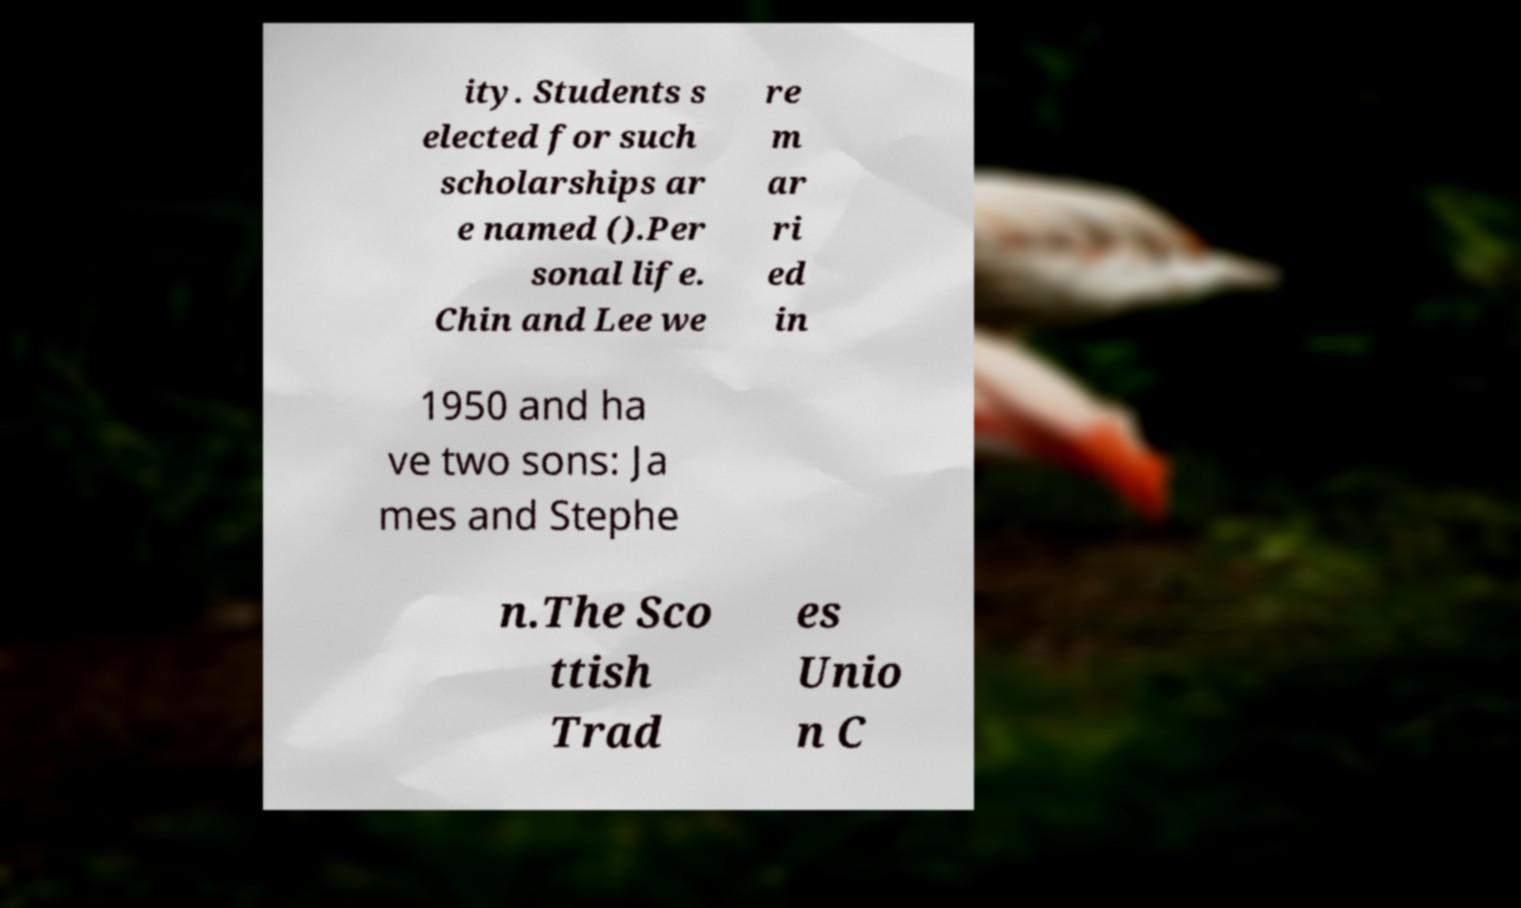Please identify and transcribe the text found in this image. ity. Students s elected for such scholarships ar e named ().Per sonal life. Chin and Lee we re m ar ri ed in 1950 and ha ve two sons: Ja mes and Stephe n.The Sco ttish Trad es Unio n C 